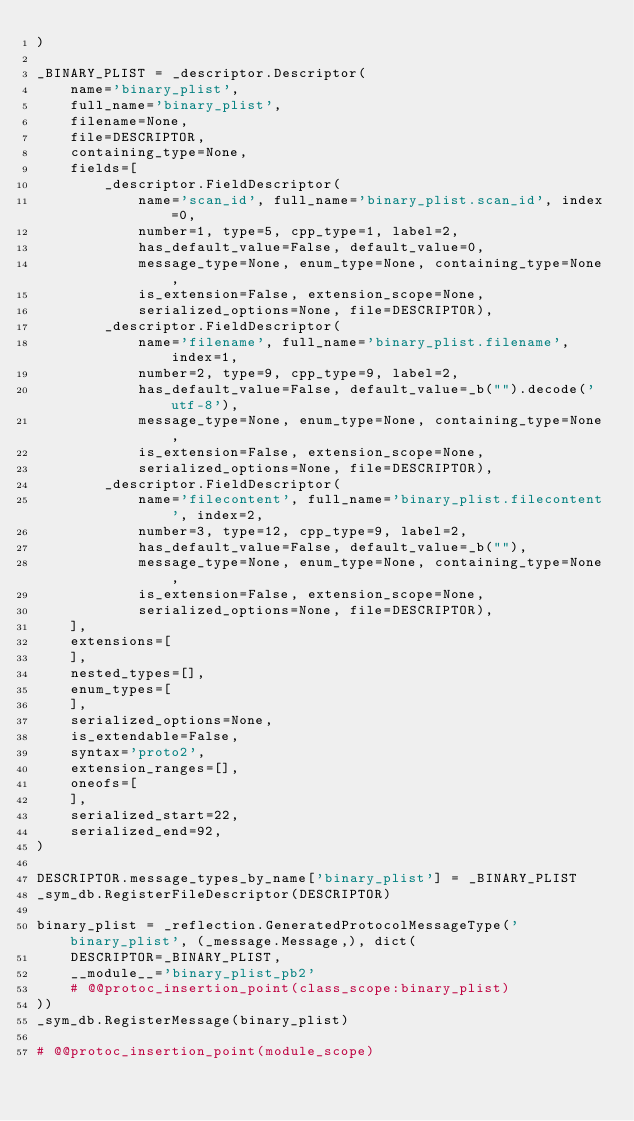Convert code to text. <code><loc_0><loc_0><loc_500><loc_500><_Python_>)

_BINARY_PLIST = _descriptor.Descriptor(
    name='binary_plist',
    full_name='binary_plist',
    filename=None,
    file=DESCRIPTOR,
    containing_type=None,
    fields=[
        _descriptor.FieldDescriptor(
            name='scan_id', full_name='binary_plist.scan_id', index=0,
            number=1, type=5, cpp_type=1, label=2,
            has_default_value=False, default_value=0,
            message_type=None, enum_type=None, containing_type=None,
            is_extension=False, extension_scope=None,
            serialized_options=None, file=DESCRIPTOR),
        _descriptor.FieldDescriptor(
            name='filename', full_name='binary_plist.filename', index=1,
            number=2, type=9, cpp_type=9, label=2,
            has_default_value=False, default_value=_b("").decode('utf-8'),
            message_type=None, enum_type=None, containing_type=None,
            is_extension=False, extension_scope=None,
            serialized_options=None, file=DESCRIPTOR),
        _descriptor.FieldDescriptor(
            name='filecontent', full_name='binary_plist.filecontent', index=2,
            number=3, type=12, cpp_type=9, label=2,
            has_default_value=False, default_value=_b(""),
            message_type=None, enum_type=None, containing_type=None,
            is_extension=False, extension_scope=None,
            serialized_options=None, file=DESCRIPTOR),
    ],
    extensions=[
    ],
    nested_types=[],
    enum_types=[
    ],
    serialized_options=None,
    is_extendable=False,
    syntax='proto2',
    extension_ranges=[],
    oneofs=[
    ],
    serialized_start=22,
    serialized_end=92,
)

DESCRIPTOR.message_types_by_name['binary_plist'] = _BINARY_PLIST
_sym_db.RegisterFileDescriptor(DESCRIPTOR)

binary_plist = _reflection.GeneratedProtocolMessageType('binary_plist', (_message.Message,), dict(
    DESCRIPTOR=_BINARY_PLIST,
    __module__='binary_plist_pb2'
    # @@protoc_insertion_point(class_scope:binary_plist)
))
_sym_db.RegisterMessage(binary_plist)

# @@protoc_insertion_point(module_scope)
</code> 